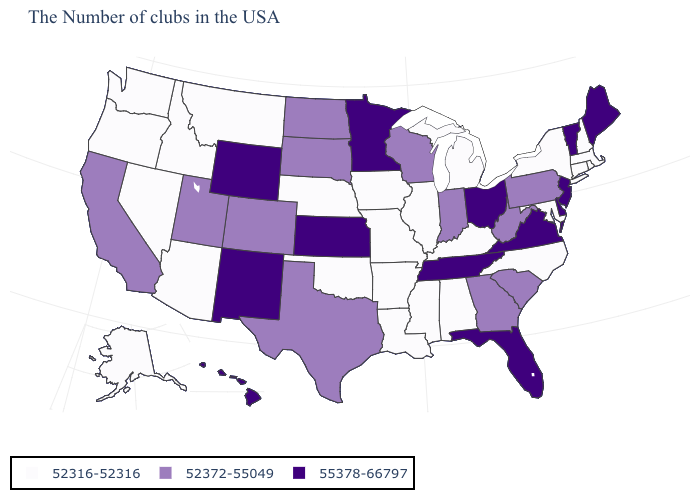Name the states that have a value in the range 52316-52316?
Be succinct. Massachusetts, Rhode Island, New Hampshire, Connecticut, New York, Maryland, North Carolina, Michigan, Kentucky, Alabama, Illinois, Mississippi, Louisiana, Missouri, Arkansas, Iowa, Nebraska, Oklahoma, Montana, Arizona, Idaho, Nevada, Washington, Oregon, Alaska. What is the value of Alaska?
Be succinct. 52316-52316. Does Nevada have the lowest value in the USA?
Write a very short answer. Yes. What is the value of South Dakota?
Give a very brief answer. 52372-55049. Name the states that have a value in the range 55378-66797?
Keep it brief. Maine, Vermont, New Jersey, Delaware, Virginia, Ohio, Florida, Tennessee, Minnesota, Kansas, Wyoming, New Mexico, Hawaii. What is the value of Texas?
Be succinct. 52372-55049. Which states have the highest value in the USA?
Write a very short answer. Maine, Vermont, New Jersey, Delaware, Virginia, Ohio, Florida, Tennessee, Minnesota, Kansas, Wyoming, New Mexico, Hawaii. What is the lowest value in states that border North Dakota?
Be succinct. 52316-52316. What is the highest value in states that border North Dakota?
Quick response, please. 55378-66797. What is the value of Missouri?
Concise answer only. 52316-52316. Does Nebraska have a lower value than Kansas?
Quick response, please. Yes. What is the value of Hawaii?
Short answer required. 55378-66797. What is the value of Florida?
Keep it brief. 55378-66797. Does Illinois have the lowest value in the USA?
Write a very short answer. Yes. What is the highest value in states that border Maryland?
Give a very brief answer. 55378-66797. 